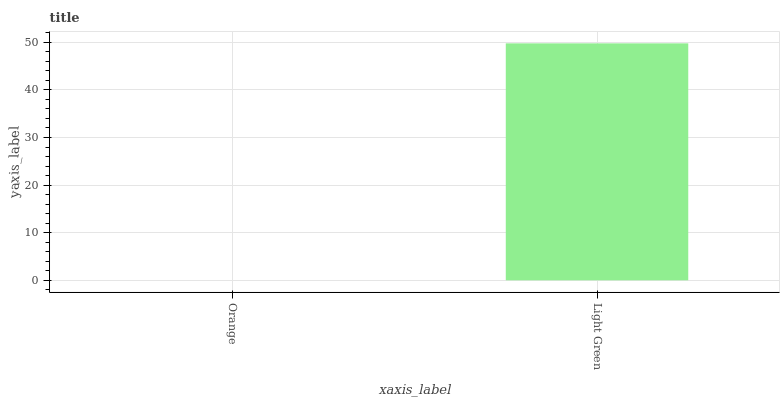Is Light Green the minimum?
Answer yes or no. No. Is Light Green greater than Orange?
Answer yes or no. Yes. Is Orange less than Light Green?
Answer yes or no. Yes. Is Orange greater than Light Green?
Answer yes or no. No. Is Light Green less than Orange?
Answer yes or no. No. Is Light Green the high median?
Answer yes or no. Yes. Is Orange the low median?
Answer yes or no. Yes. Is Orange the high median?
Answer yes or no. No. Is Light Green the low median?
Answer yes or no. No. 